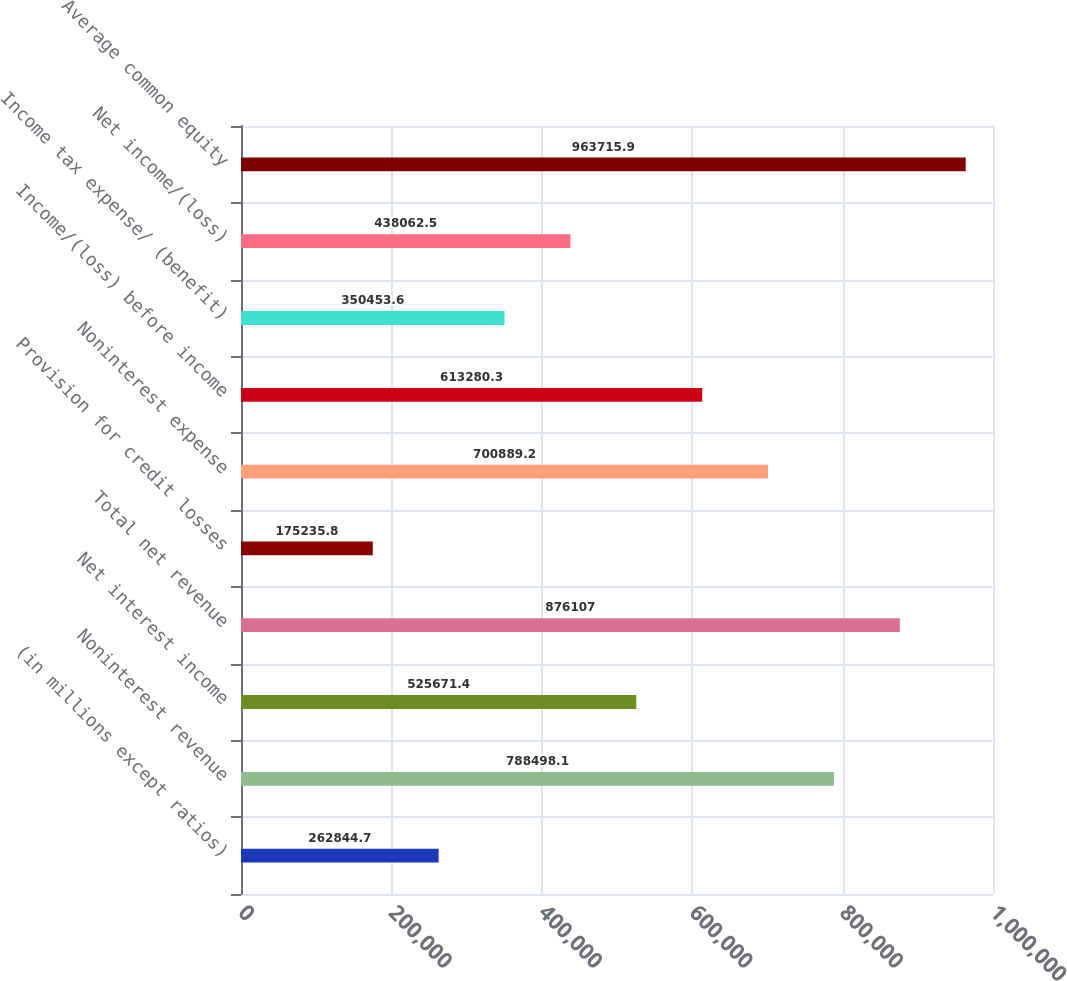<chart> <loc_0><loc_0><loc_500><loc_500><bar_chart><fcel>(in millions except ratios)<fcel>Noninterest revenue<fcel>Net interest income<fcel>Total net revenue<fcel>Provision for credit losses<fcel>Noninterest expense<fcel>Income/(loss) before income<fcel>Income tax expense/ (benefit)<fcel>Net income/(loss)<fcel>Average common equity<nl><fcel>262845<fcel>788498<fcel>525671<fcel>876107<fcel>175236<fcel>700889<fcel>613280<fcel>350454<fcel>438062<fcel>963716<nl></chart> 